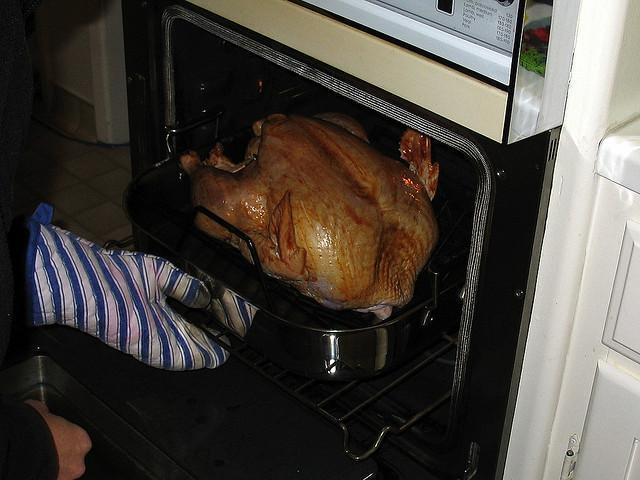Is the caption "The oven is at the left side of the person." a true representation of the image?
Answer yes or no. No. 